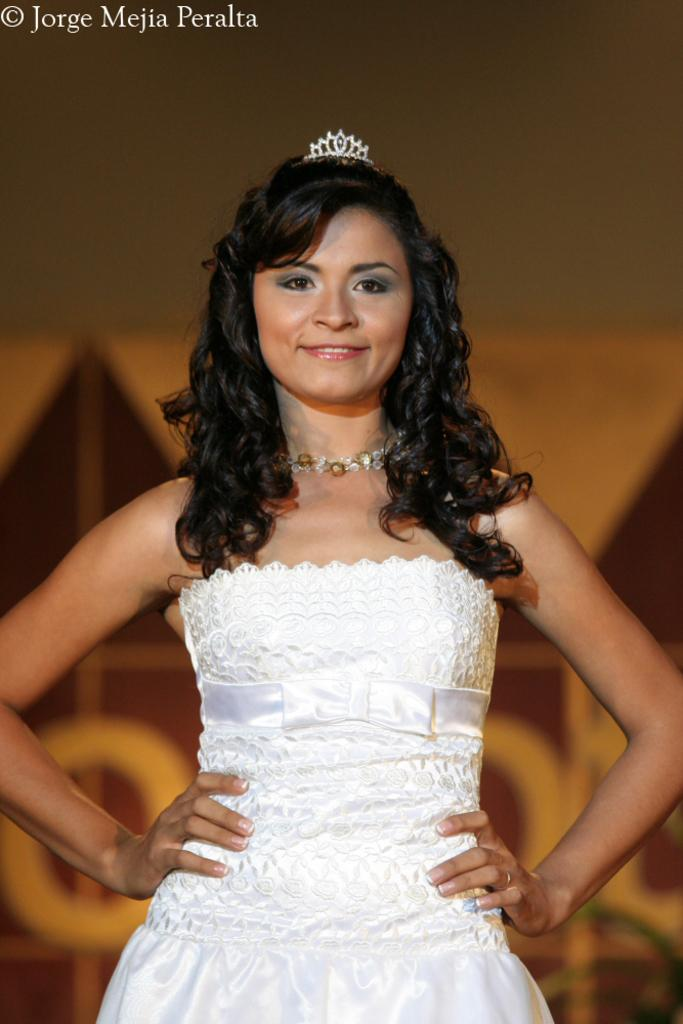What is the main subject of the image? There is a woman in the image. What is the woman doing in the image? The woman is standing and smiling. Can you describe the background of the image? The background of the image is blurry. Is there any text present in the image? Yes, there is some text at the top of the image. What is the woman wearing in the image? The woman is wearing a white dress. What type of toothbrush can be seen in the woman's hand in the image? There is no toothbrush present in the image. Can you tell me how many horses are visible in the background of the image? There are no horses visible in the background of the image. 